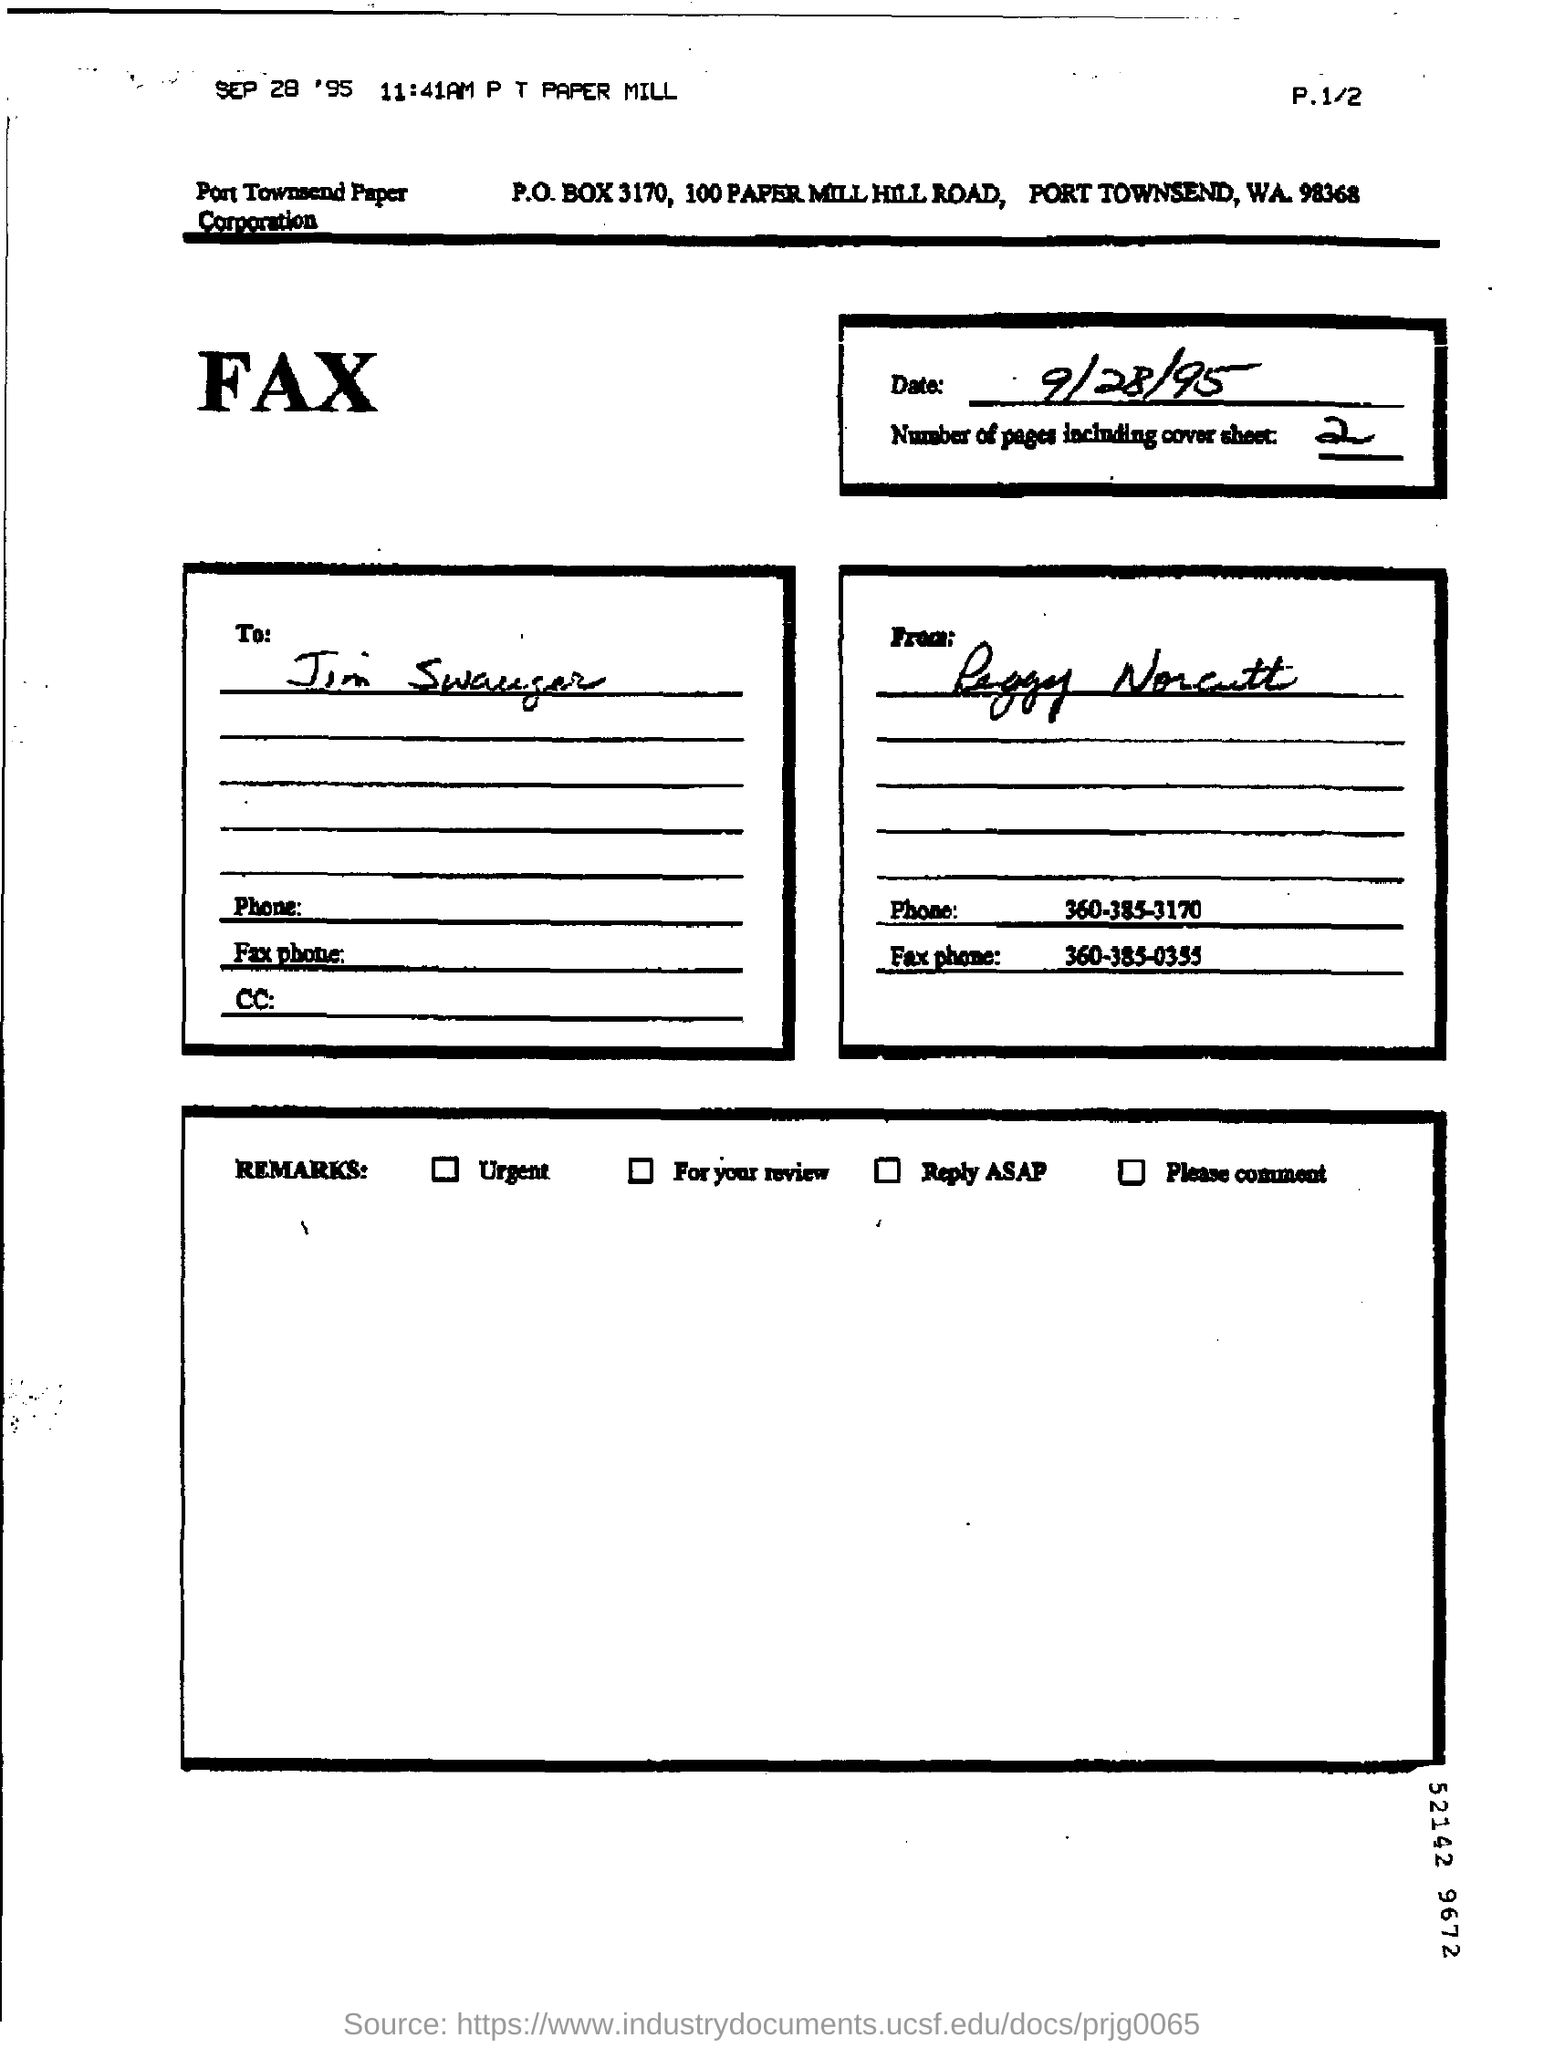Give some essential details in this illustration. The P.O.BOX number is 3170. There are two pages including the cover sheet. The phone number mentioned in the fax is 360-385-3170. The fax phone number is 360-385-0355. 